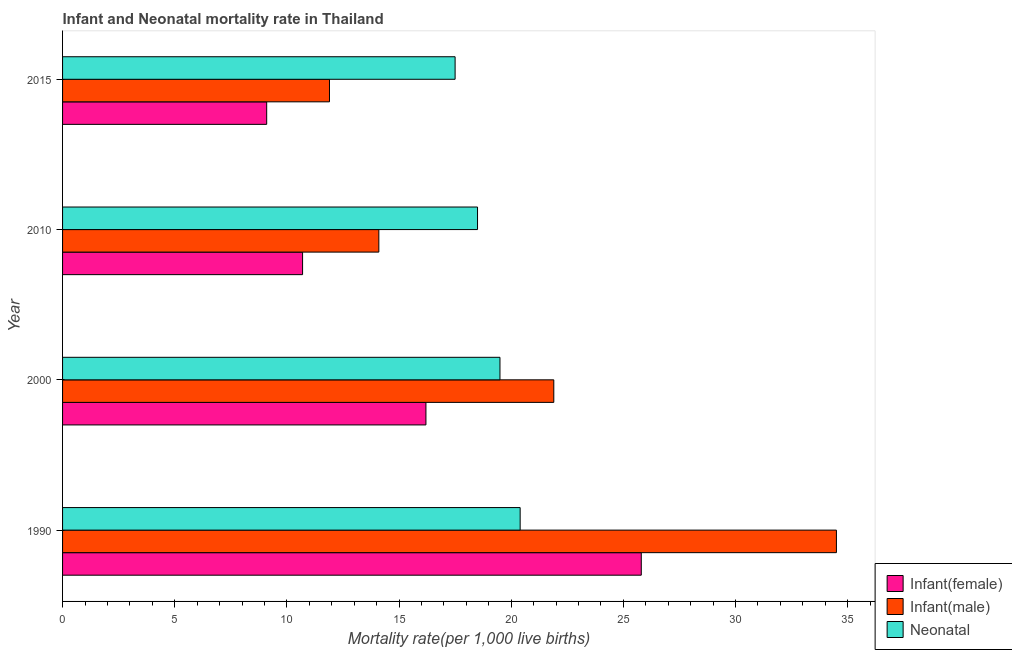How many groups of bars are there?
Your answer should be compact. 4. Are the number of bars on each tick of the Y-axis equal?
Ensure brevity in your answer.  Yes. What is the label of the 2nd group of bars from the top?
Your answer should be very brief. 2010. Across all years, what is the maximum neonatal mortality rate?
Your response must be concise. 20.4. In which year was the infant mortality rate(female) maximum?
Offer a terse response. 1990. In which year was the infant mortality rate(female) minimum?
Your response must be concise. 2015. What is the total infant mortality rate(female) in the graph?
Offer a very short reply. 61.8. What is the difference between the infant mortality rate(female) in 1990 and that in 2015?
Your response must be concise. 16.7. What is the difference between the infant mortality rate(male) in 2000 and the infant mortality rate(female) in 1990?
Provide a succinct answer. -3.9. What is the average infant mortality rate(male) per year?
Provide a succinct answer. 20.6. In the year 2010, what is the difference between the neonatal mortality rate and infant mortality rate(male)?
Provide a short and direct response. 4.4. In how many years, is the neonatal mortality rate greater than 16 ?
Provide a short and direct response. 4. What is the ratio of the infant mortality rate(female) in 1990 to that in 2000?
Your response must be concise. 1.59. Is the infant mortality rate(male) in 1990 less than that in 2000?
Make the answer very short. No. Is the difference between the neonatal mortality rate in 2000 and 2015 greater than the difference between the infant mortality rate(male) in 2000 and 2015?
Ensure brevity in your answer.  No. What is the difference between the highest and the lowest infant mortality rate(male)?
Offer a very short reply. 22.6. What does the 1st bar from the top in 2000 represents?
Keep it short and to the point. Neonatal . What does the 1st bar from the bottom in 2015 represents?
Your answer should be very brief. Infant(female). How many bars are there?
Give a very brief answer. 12. Are all the bars in the graph horizontal?
Keep it short and to the point. Yes. Are the values on the major ticks of X-axis written in scientific E-notation?
Ensure brevity in your answer.  No. Where does the legend appear in the graph?
Ensure brevity in your answer.  Bottom right. How many legend labels are there?
Offer a terse response. 3. What is the title of the graph?
Provide a succinct answer. Infant and Neonatal mortality rate in Thailand. Does "Coal" appear as one of the legend labels in the graph?
Your answer should be compact. No. What is the label or title of the X-axis?
Offer a terse response. Mortality rate(per 1,0 live births). What is the label or title of the Y-axis?
Keep it short and to the point. Year. What is the Mortality rate(per 1,000 live births) of Infant(female) in 1990?
Give a very brief answer. 25.8. What is the Mortality rate(per 1,000 live births) in Infant(male) in 1990?
Keep it short and to the point. 34.5. What is the Mortality rate(per 1,000 live births) in Neonatal  in 1990?
Keep it short and to the point. 20.4. What is the Mortality rate(per 1,000 live births) in Infant(female) in 2000?
Ensure brevity in your answer.  16.2. What is the Mortality rate(per 1,000 live births) in Infant(male) in 2000?
Provide a short and direct response. 21.9. What is the Mortality rate(per 1,000 live births) in Infant(male) in 2010?
Your answer should be compact. 14.1. What is the Mortality rate(per 1,000 live births) in Neonatal  in 2010?
Your response must be concise. 18.5. What is the Mortality rate(per 1,000 live births) of Neonatal  in 2015?
Keep it short and to the point. 17.5. Across all years, what is the maximum Mortality rate(per 1,000 live births) in Infant(female)?
Offer a terse response. 25.8. Across all years, what is the maximum Mortality rate(per 1,000 live births) of Infant(male)?
Make the answer very short. 34.5. Across all years, what is the maximum Mortality rate(per 1,000 live births) in Neonatal ?
Offer a terse response. 20.4. Across all years, what is the minimum Mortality rate(per 1,000 live births) of Infant(female)?
Provide a succinct answer. 9.1. What is the total Mortality rate(per 1,000 live births) in Infant(female) in the graph?
Ensure brevity in your answer.  61.8. What is the total Mortality rate(per 1,000 live births) in Infant(male) in the graph?
Give a very brief answer. 82.4. What is the total Mortality rate(per 1,000 live births) in Neonatal  in the graph?
Keep it short and to the point. 75.9. What is the difference between the Mortality rate(per 1,000 live births) of Infant(male) in 1990 and that in 2000?
Offer a terse response. 12.6. What is the difference between the Mortality rate(per 1,000 live births) in Neonatal  in 1990 and that in 2000?
Your response must be concise. 0.9. What is the difference between the Mortality rate(per 1,000 live births) of Infant(male) in 1990 and that in 2010?
Give a very brief answer. 20.4. What is the difference between the Mortality rate(per 1,000 live births) of Infant(female) in 1990 and that in 2015?
Your answer should be very brief. 16.7. What is the difference between the Mortality rate(per 1,000 live births) in Infant(male) in 1990 and that in 2015?
Provide a succinct answer. 22.6. What is the difference between the Mortality rate(per 1,000 live births) of Infant(female) in 2000 and that in 2010?
Your response must be concise. 5.5. What is the difference between the Mortality rate(per 1,000 live births) of Neonatal  in 2000 and that in 2010?
Keep it short and to the point. 1. What is the difference between the Mortality rate(per 1,000 live births) of Infant(male) in 2000 and that in 2015?
Provide a short and direct response. 10. What is the difference between the Mortality rate(per 1,000 live births) in Neonatal  in 2000 and that in 2015?
Provide a short and direct response. 2. What is the difference between the Mortality rate(per 1,000 live births) in Infant(female) in 2010 and that in 2015?
Your answer should be compact. 1.6. What is the difference between the Mortality rate(per 1,000 live births) of Infant(female) in 1990 and the Mortality rate(per 1,000 live births) of Infant(male) in 2000?
Give a very brief answer. 3.9. What is the difference between the Mortality rate(per 1,000 live births) in Infant(female) in 1990 and the Mortality rate(per 1,000 live births) in Neonatal  in 2000?
Offer a very short reply. 6.3. What is the difference between the Mortality rate(per 1,000 live births) in Infant(male) in 1990 and the Mortality rate(per 1,000 live births) in Neonatal  in 2015?
Make the answer very short. 17. What is the difference between the Mortality rate(per 1,000 live births) of Infant(female) in 2000 and the Mortality rate(per 1,000 live births) of Infant(male) in 2010?
Offer a terse response. 2.1. What is the difference between the Mortality rate(per 1,000 live births) in Infant(male) in 2000 and the Mortality rate(per 1,000 live births) in Neonatal  in 2010?
Your response must be concise. 3.4. What is the difference between the Mortality rate(per 1,000 live births) in Infant(male) in 2000 and the Mortality rate(per 1,000 live births) in Neonatal  in 2015?
Your answer should be compact. 4.4. What is the difference between the Mortality rate(per 1,000 live births) in Infant(female) in 2010 and the Mortality rate(per 1,000 live births) in Infant(male) in 2015?
Keep it short and to the point. -1.2. What is the difference between the Mortality rate(per 1,000 live births) in Infant(male) in 2010 and the Mortality rate(per 1,000 live births) in Neonatal  in 2015?
Offer a terse response. -3.4. What is the average Mortality rate(per 1,000 live births) in Infant(female) per year?
Offer a very short reply. 15.45. What is the average Mortality rate(per 1,000 live births) of Infant(male) per year?
Keep it short and to the point. 20.6. What is the average Mortality rate(per 1,000 live births) of Neonatal  per year?
Your response must be concise. 18.98. In the year 1990, what is the difference between the Mortality rate(per 1,000 live births) of Infant(female) and Mortality rate(per 1,000 live births) of Infant(male)?
Offer a terse response. -8.7. In the year 1990, what is the difference between the Mortality rate(per 1,000 live births) of Infant(male) and Mortality rate(per 1,000 live births) of Neonatal ?
Your answer should be very brief. 14.1. In the year 2000, what is the difference between the Mortality rate(per 1,000 live births) in Infant(female) and Mortality rate(per 1,000 live births) in Neonatal ?
Provide a succinct answer. -3.3. In the year 2010, what is the difference between the Mortality rate(per 1,000 live births) in Infant(male) and Mortality rate(per 1,000 live births) in Neonatal ?
Provide a succinct answer. -4.4. In the year 2015, what is the difference between the Mortality rate(per 1,000 live births) of Infant(female) and Mortality rate(per 1,000 live births) of Neonatal ?
Give a very brief answer. -8.4. In the year 2015, what is the difference between the Mortality rate(per 1,000 live births) of Infant(male) and Mortality rate(per 1,000 live births) of Neonatal ?
Give a very brief answer. -5.6. What is the ratio of the Mortality rate(per 1,000 live births) of Infant(female) in 1990 to that in 2000?
Your answer should be very brief. 1.59. What is the ratio of the Mortality rate(per 1,000 live births) in Infant(male) in 1990 to that in 2000?
Give a very brief answer. 1.58. What is the ratio of the Mortality rate(per 1,000 live births) in Neonatal  in 1990 to that in 2000?
Offer a terse response. 1.05. What is the ratio of the Mortality rate(per 1,000 live births) of Infant(female) in 1990 to that in 2010?
Your answer should be compact. 2.41. What is the ratio of the Mortality rate(per 1,000 live births) of Infant(male) in 1990 to that in 2010?
Your response must be concise. 2.45. What is the ratio of the Mortality rate(per 1,000 live births) of Neonatal  in 1990 to that in 2010?
Your response must be concise. 1.1. What is the ratio of the Mortality rate(per 1,000 live births) of Infant(female) in 1990 to that in 2015?
Offer a terse response. 2.84. What is the ratio of the Mortality rate(per 1,000 live births) of Infant(male) in 1990 to that in 2015?
Offer a terse response. 2.9. What is the ratio of the Mortality rate(per 1,000 live births) of Neonatal  in 1990 to that in 2015?
Keep it short and to the point. 1.17. What is the ratio of the Mortality rate(per 1,000 live births) of Infant(female) in 2000 to that in 2010?
Your answer should be very brief. 1.51. What is the ratio of the Mortality rate(per 1,000 live births) in Infant(male) in 2000 to that in 2010?
Offer a terse response. 1.55. What is the ratio of the Mortality rate(per 1,000 live births) in Neonatal  in 2000 to that in 2010?
Offer a very short reply. 1.05. What is the ratio of the Mortality rate(per 1,000 live births) in Infant(female) in 2000 to that in 2015?
Provide a succinct answer. 1.78. What is the ratio of the Mortality rate(per 1,000 live births) of Infant(male) in 2000 to that in 2015?
Provide a short and direct response. 1.84. What is the ratio of the Mortality rate(per 1,000 live births) of Neonatal  in 2000 to that in 2015?
Your response must be concise. 1.11. What is the ratio of the Mortality rate(per 1,000 live births) in Infant(female) in 2010 to that in 2015?
Your answer should be compact. 1.18. What is the ratio of the Mortality rate(per 1,000 live births) of Infant(male) in 2010 to that in 2015?
Your answer should be compact. 1.18. What is the ratio of the Mortality rate(per 1,000 live births) of Neonatal  in 2010 to that in 2015?
Keep it short and to the point. 1.06. What is the difference between the highest and the lowest Mortality rate(per 1,000 live births) in Infant(female)?
Ensure brevity in your answer.  16.7. What is the difference between the highest and the lowest Mortality rate(per 1,000 live births) in Infant(male)?
Provide a succinct answer. 22.6. 